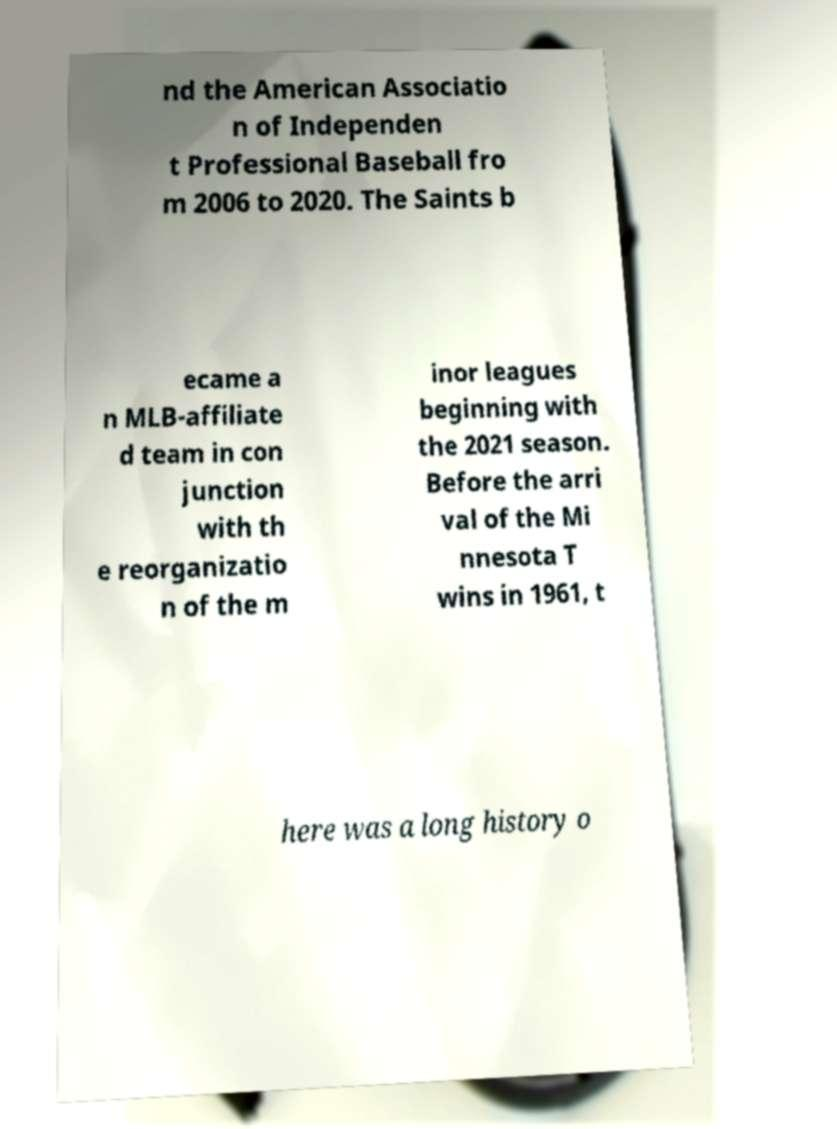Could you extract and type out the text from this image? nd the American Associatio n of Independen t Professional Baseball fro m 2006 to 2020. The Saints b ecame a n MLB-affiliate d team in con junction with th e reorganizatio n of the m inor leagues beginning with the 2021 season. Before the arri val of the Mi nnesota T wins in 1961, t here was a long history o 